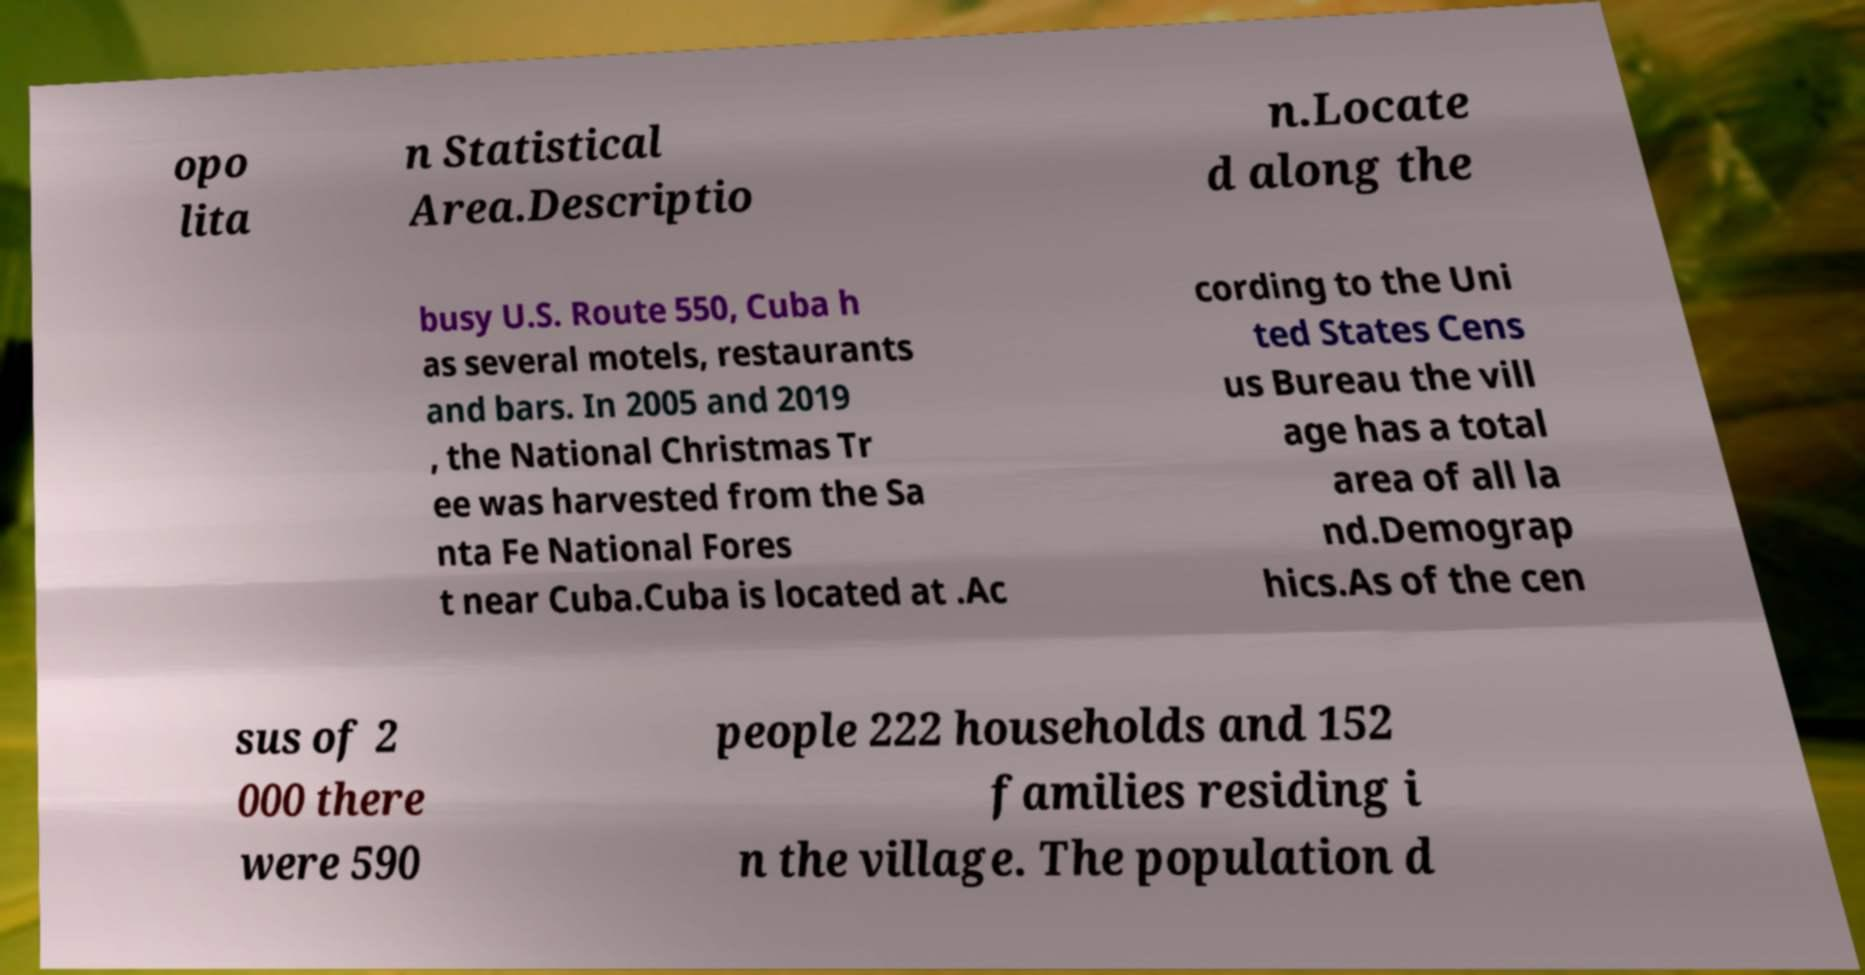Please identify and transcribe the text found in this image. opo lita n Statistical Area.Descriptio n.Locate d along the busy U.S. Route 550, Cuba h as several motels, restaurants and bars. In 2005 and 2019 , the National Christmas Tr ee was harvested from the Sa nta Fe National Fores t near Cuba.Cuba is located at .Ac cording to the Uni ted States Cens us Bureau the vill age has a total area of all la nd.Demograp hics.As of the cen sus of 2 000 there were 590 people 222 households and 152 families residing i n the village. The population d 